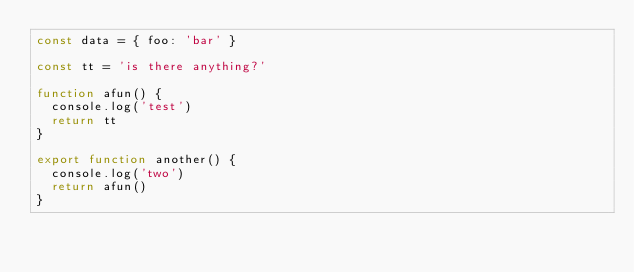Convert code to text. <code><loc_0><loc_0><loc_500><loc_500><_JavaScript_>const data = { foo: 'bar' }

const tt = 'is there anything?'

function afun() {
  console.log('test')
  return tt
}

export function another() {
  console.log('two')
  return afun()
}
</code> 